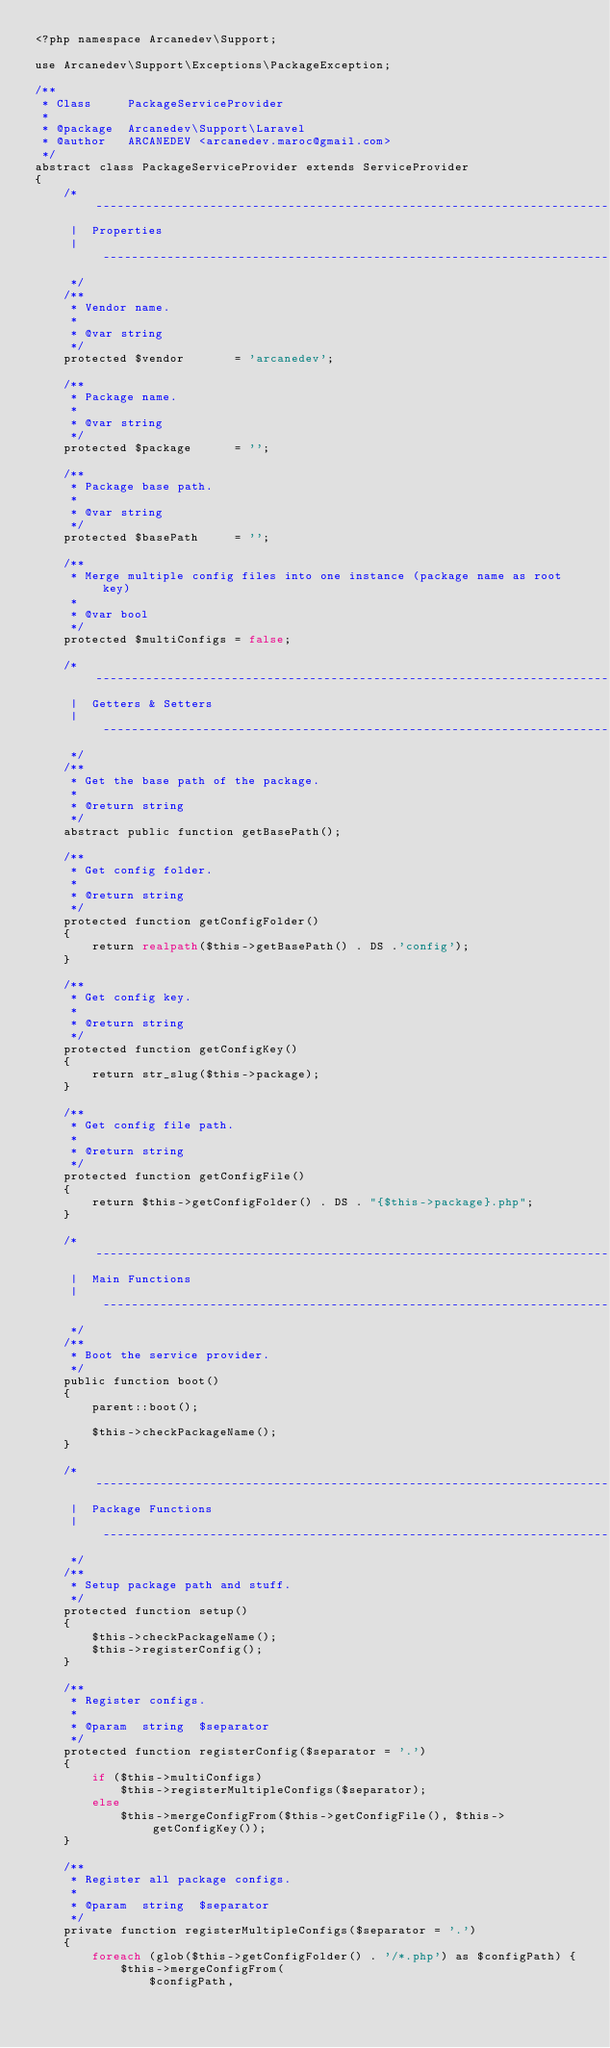Convert code to text. <code><loc_0><loc_0><loc_500><loc_500><_PHP_><?php namespace Arcanedev\Support;

use Arcanedev\Support\Exceptions\PackageException;

/**
 * Class     PackageServiceProvider
 *
 * @package  Arcanedev\Support\Laravel
 * @author   ARCANEDEV <arcanedev.maroc@gmail.com>
 */
abstract class PackageServiceProvider extends ServiceProvider
{
    /* ------------------------------------------------------------------------------------------------
     |  Properties
     | ------------------------------------------------------------------------------------------------
     */
    /**
     * Vendor name.
     *
     * @var string
     */
    protected $vendor       = 'arcanedev';

    /**
     * Package name.
     *
     * @var string
     */
    protected $package      = '';

    /**
     * Package base path.
     *
     * @var string
     */
    protected $basePath     = '';

    /**
     * Merge multiple config files into one instance (package name as root key)
     *
     * @var bool
     */
    protected $multiConfigs = false;

    /* ------------------------------------------------------------------------------------------------
     |  Getters & Setters
     | ------------------------------------------------------------------------------------------------
     */
    /**
     * Get the base path of the package.
     *
     * @return string
     */
    abstract public function getBasePath();

    /**
     * Get config folder.
     *
     * @return string
     */
    protected function getConfigFolder()
    {
        return realpath($this->getBasePath() . DS .'config');
    }

    /**
     * Get config key.
     *
     * @return string
     */
    protected function getConfigKey()
    {
        return str_slug($this->package);
    }

    /**
     * Get config file path.
     *
     * @return string
     */
    protected function getConfigFile()
    {
        return $this->getConfigFolder() . DS . "{$this->package}.php";
    }

    /* ------------------------------------------------------------------------------------------------
     |  Main Functions
     | ------------------------------------------------------------------------------------------------
     */
    /**
     * Boot the service provider.
     */
    public function boot()
    {
        parent::boot();

        $this->checkPackageName();
    }

    /* ------------------------------------------------------------------------------------------------
     |  Package Functions
     | ------------------------------------------------------------------------------------------------
     */
    /**
     * Setup package path and stuff.
     */
    protected function setup()
    {
        $this->checkPackageName();
        $this->registerConfig();
    }

    /**
     * Register configs.
     *
     * @param  string  $separator
     */
    protected function registerConfig($separator = '.')
    {
        if ($this->multiConfigs)
            $this->registerMultipleConfigs($separator);
        else
            $this->mergeConfigFrom($this->getConfigFile(), $this->getConfigKey());
    }

    /**
     * Register all package configs.
     *
     * @param  string  $separator
     */
    private function registerMultipleConfigs($separator = '.')
    {
        foreach (glob($this->getConfigFolder() . '/*.php') as $configPath) {
            $this->mergeConfigFrom(
                $configPath,</code> 